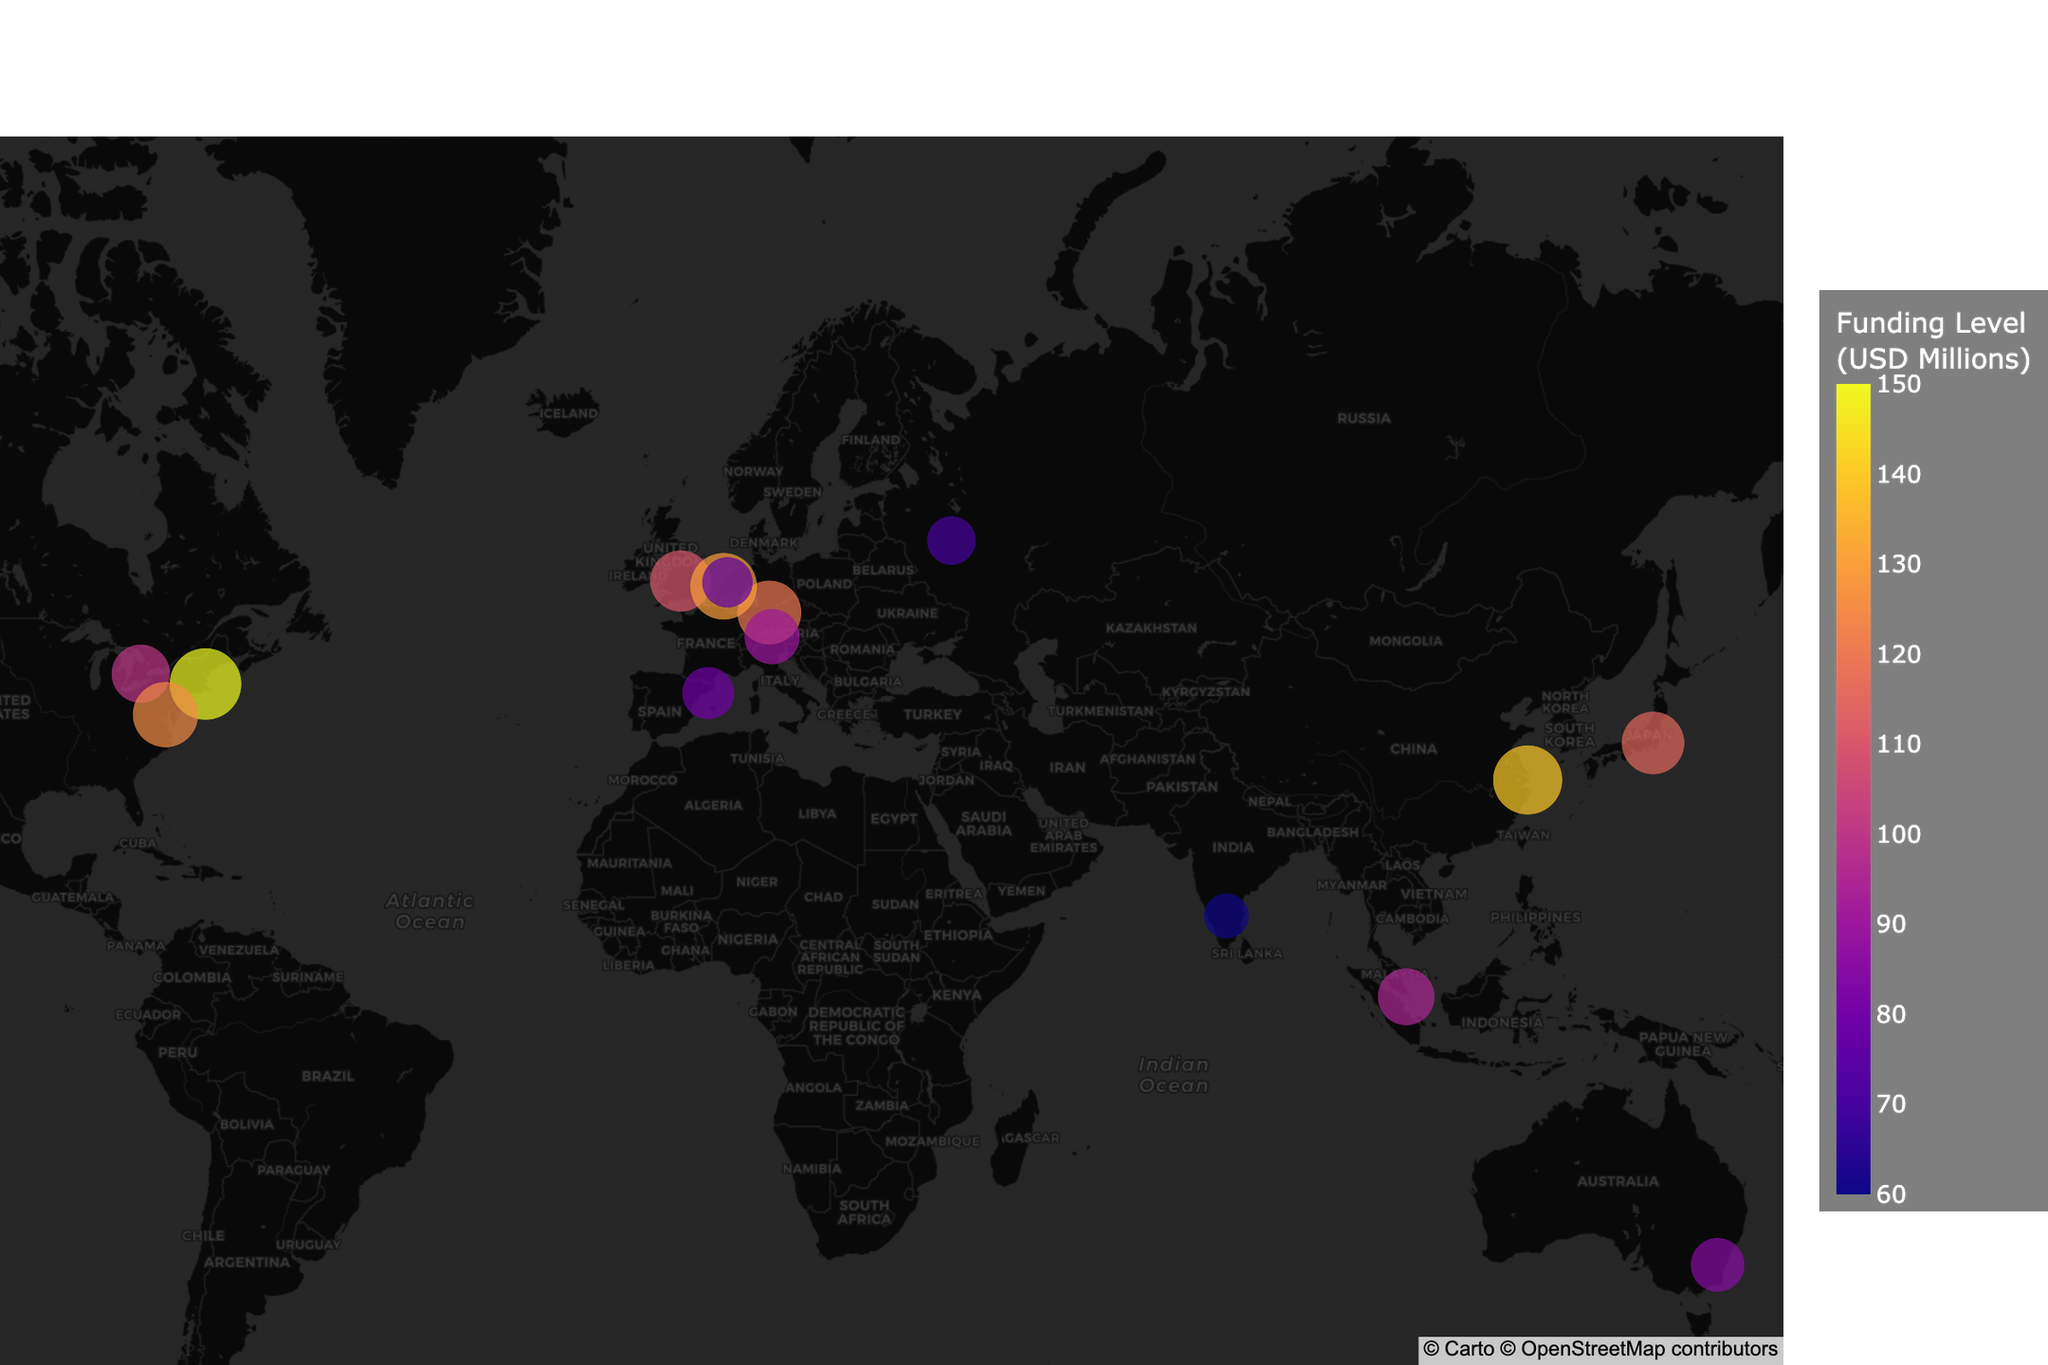What is the title of the figure? The title is prominently displayed at the top of the plot in larger font size. It provides a summary or an overview of what the figure represents.
Answer: Global Distribution of Quantum Research Institutions and Funding Levels Which institution has the highest funding level? The size and color intensity of each data point represent the funding level. The institution with the largest circle and most intense color has the highest funding level.
Answer: Harvard Quantum Initiative How many institutions are located in Europe? Identify the institutions by spotting their geographic location on the map, particularly within the European continent boundaries.
Answer: 5 What is the funding level of the Institute for Quantum Computing in Canada? Hover over the data point located in Canada on the map to get details such as the funding level.
Answer: 100 million USD Which country has the most institutions listed? Locate each institution and count the number of institutions within each country’s geographic boundaries.
Answer: Netherlands What is the total funding level of institutions in the USA? Identify the institutions in the USA and sum their funding levels.
Answer: 275 million USD Which institution is marked with the smallest size circle? The circle size corresponds to the funding level, so the smallest circle represents the institution with the lowest funding level.
Answer: Centre for Quantum Technologies, India Are there more institutions in the Northern Hemisphere or Southern Hemisphere? Count the number of institutions located above and below the equator line on the map.
Answer: Northern Hemisphere Which Asian institution has the highest funding level? Focus on the data points within Asia and identify which one has the largest size or most intense color.
Answer: Shanghai Institute of Microsystem and Information Technology How does the funding level of QuTech in Netherlands compare to the Centre for Quantum Technologies in Singapore? Locate the data points for QuTech and Centre for Quantum Technologies on the map and compare their circle sizes or color intensities.
Answer: QuTech has a higher funding level than Centre for Quantum Technologies in Singapore 